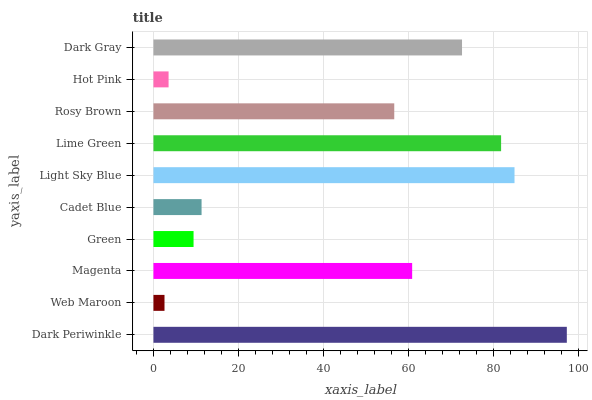Is Web Maroon the minimum?
Answer yes or no. Yes. Is Dark Periwinkle the maximum?
Answer yes or no. Yes. Is Magenta the minimum?
Answer yes or no. No. Is Magenta the maximum?
Answer yes or no. No. Is Magenta greater than Web Maroon?
Answer yes or no. Yes. Is Web Maroon less than Magenta?
Answer yes or no. Yes. Is Web Maroon greater than Magenta?
Answer yes or no. No. Is Magenta less than Web Maroon?
Answer yes or no. No. Is Magenta the high median?
Answer yes or no. Yes. Is Rosy Brown the low median?
Answer yes or no. Yes. Is Lime Green the high median?
Answer yes or no. No. Is Dark Periwinkle the low median?
Answer yes or no. No. 